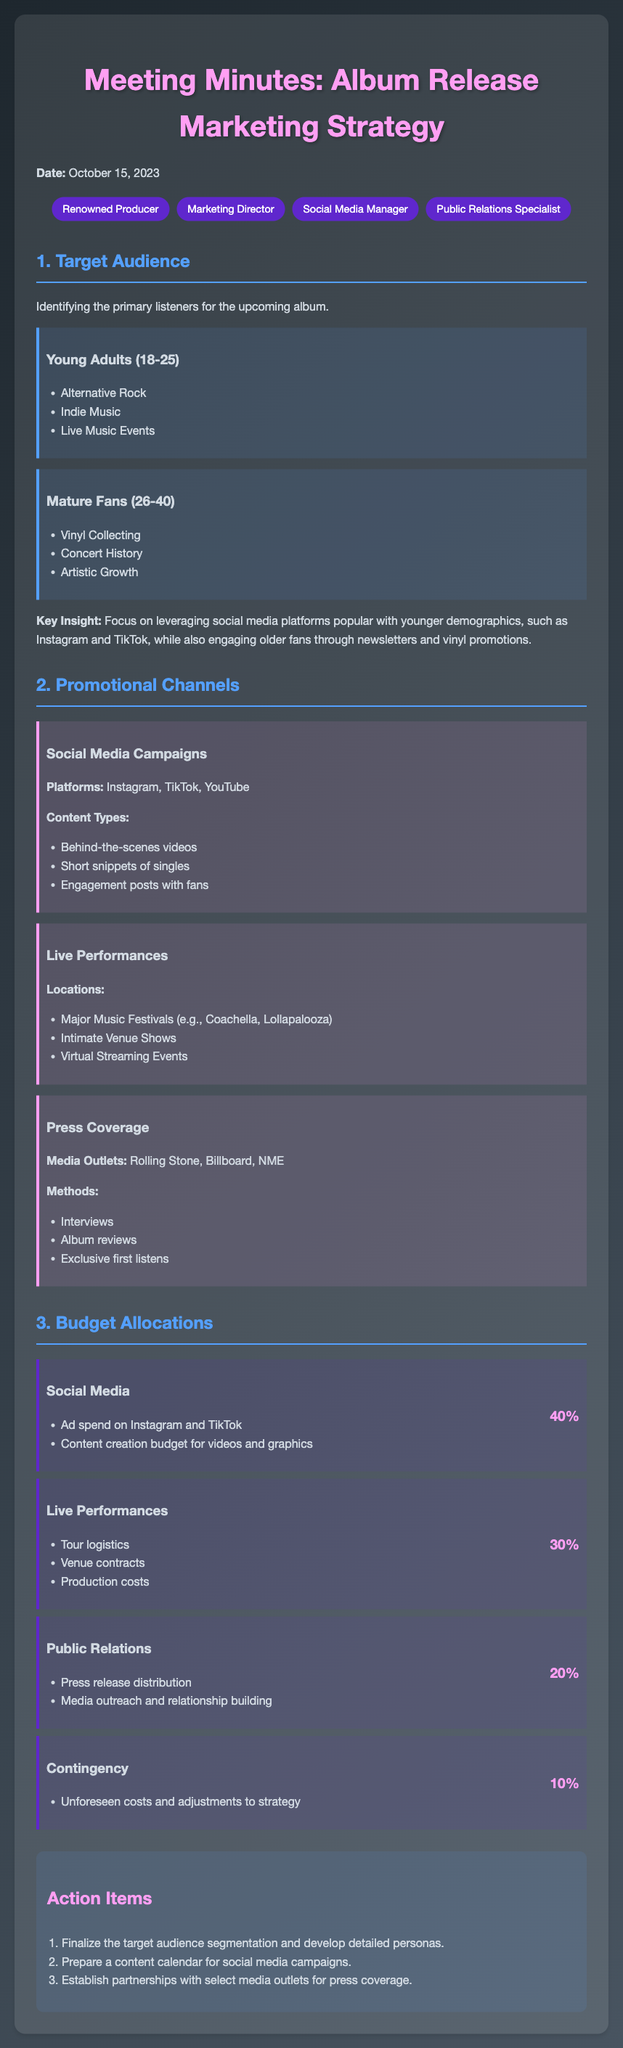What is the date of the meeting? The date of the meeting is specified at the beginning of the document.
Answer: October 15, 2023 Who is the marketing director? The attendees section lists the roles of individuals present, including the marketing director.
Answer: Marketing Director What percentage of the budget is allocated to social media? The budget allocations section provides a breakdown of the budget, including percentages for each category.
Answer: 40% Which platforms were identified for social media campaigns? The promotional channels section outlines the specific platforms to be used for social media campaigns.
Answer: Instagram, TikTok, YouTube What is the target audience segment for young adults? The target audience section lists specific demographics and their interests, including young adults.
Answer: 18-25 How many action items were listed? The action items section specifies the number of tasks identified for follow-up.
Answer: 3 What is the primary content type for social media? The promotional channels section describes what content types will be utilized on social media.
Answer: Behind-the-scenes videos What is included in the public relations budget allocation? The budget allocations section outlines specific activities under the public relations category.
Answer: Press release distribution, Media outreach and relationship building Where will the live performances take place? The promotional channels section details the locations for live performances.
Answer: Major Music Festivals, Intimate Venue Shows, Virtual Streaming Events 